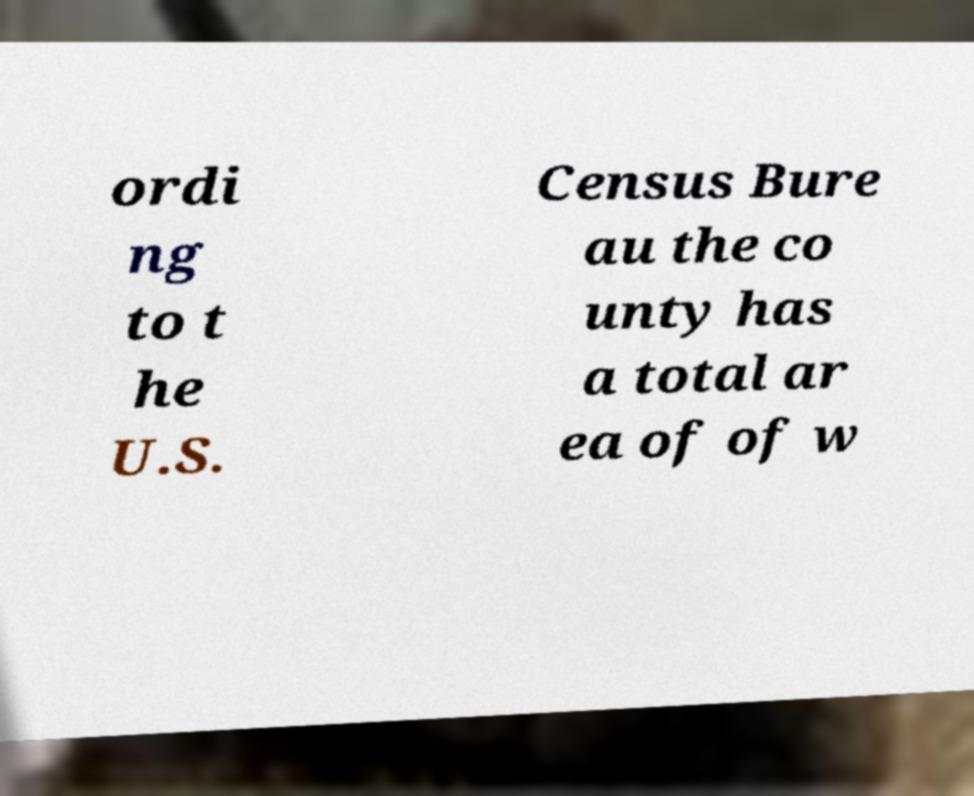For documentation purposes, I need the text within this image transcribed. Could you provide that? ordi ng to t he U.S. Census Bure au the co unty has a total ar ea of of w 